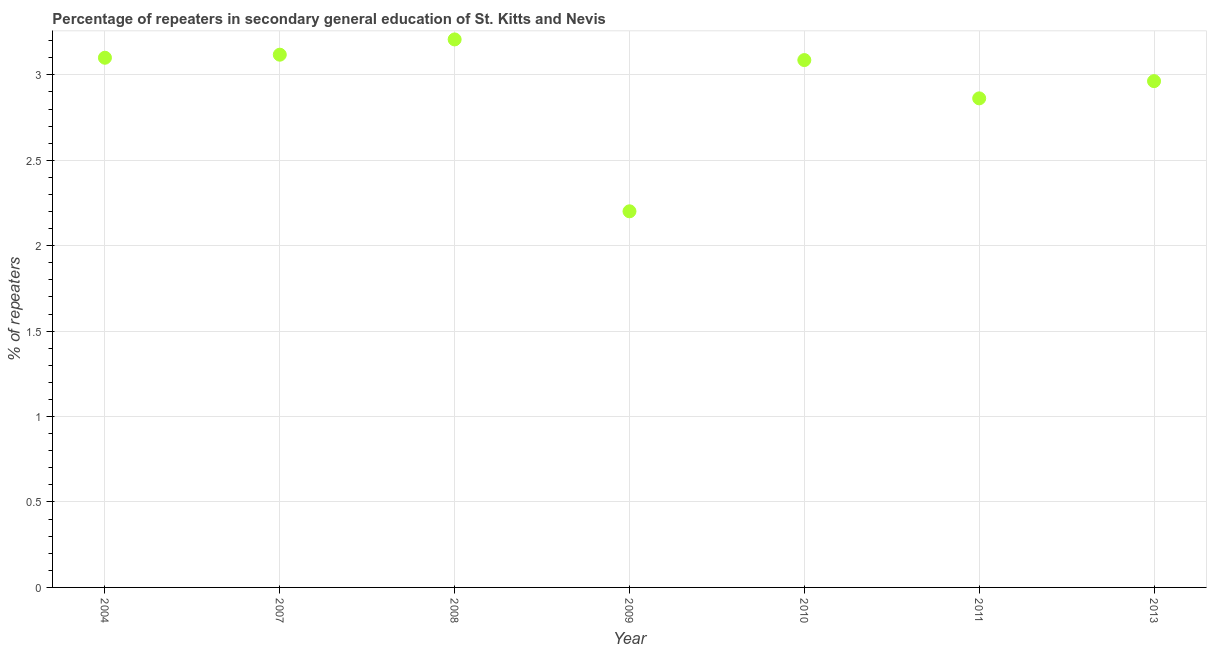What is the percentage of repeaters in 2009?
Make the answer very short. 2.2. Across all years, what is the maximum percentage of repeaters?
Keep it short and to the point. 3.21. Across all years, what is the minimum percentage of repeaters?
Offer a very short reply. 2.2. In which year was the percentage of repeaters minimum?
Offer a very short reply. 2009. What is the sum of the percentage of repeaters?
Ensure brevity in your answer.  20.54. What is the difference between the percentage of repeaters in 2009 and 2010?
Give a very brief answer. -0.89. What is the average percentage of repeaters per year?
Provide a short and direct response. 2.93. What is the median percentage of repeaters?
Offer a terse response. 3.09. In how many years, is the percentage of repeaters greater than 2.6 %?
Offer a terse response. 6. Do a majority of the years between 2009 and 2008 (inclusive) have percentage of repeaters greater than 2.1 %?
Give a very brief answer. No. What is the ratio of the percentage of repeaters in 2010 to that in 2013?
Offer a terse response. 1.04. Is the percentage of repeaters in 2009 less than that in 2011?
Ensure brevity in your answer.  Yes. What is the difference between the highest and the second highest percentage of repeaters?
Provide a short and direct response. 0.09. Is the sum of the percentage of repeaters in 2004 and 2007 greater than the maximum percentage of repeaters across all years?
Make the answer very short. Yes. What is the difference between the highest and the lowest percentage of repeaters?
Provide a short and direct response. 1.01. In how many years, is the percentage of repeaters greater than the average percentage of repeaters taken over all years?
Make the answer very short. 5. How many years are there in the graph?
Make the answer very short. 7. Are the values on the major ticks of Y-axis written in scientific E-notation?
Offer a terse response. No. Does the graph contain any zero values?
Offer a terse response. No. Does the graph contain grids?
Your response must be concise. Yes. What is the title of the graph?
Provide a succinct answer. Percentage of repeaters in secondary general education of St. Kitts and Nevis. What is the label or title of the Y-axis?
Keep it short and to the point. % of repeaters. What is the % of repeaters in 2004?
Keep it short and to the point. 3.1. What is the % of repeaters in 2007?
Give a very brief answer. 3.12. What is the % of repeaters in 2008?
Provide a succinct answer. 3.21. What is the % of repeaters in 2009?
Give a very brief answer. 2.2. What is the % of repeaters in 2010?
Make the answer very short. 3.09. What is the % of repeaters in 2011?
Your answer should be very brief. 2.86. What is the % of repeaters in 2013?
Provide a short and direct response. 2.96. What is the difference between the % of repeaters in 2004 and 2007?
Provide a short and direct response. -0.02. What is the difference between the % of repeaters in 2004 and 2008?
Give a very brief answer. -0.11. What is the difference between the % of repeaters in 2004 and 2009?
Provide a succinct answer. 0.9. What is the difference between the % of repeaters in 2004 and 2010?
Offer a very short reply. 0.01. What is the difference between the % of repeaters in 2004 and 2011?
Make the answer very short. 0.24. What is the difference between the % of repeaters in 2004 and 2013?
Your answer should be compact. 0.14. What is the difference between the % of repeaters in 2007 and 2008?
Provide a succinct answer. -0.09. What is the difference between the % of repeaters in 2007 and 2009?
Give a very brief answer. 0.92. What is the difference between the % of repeaters in 2007 and 2010?
Keep it short and to the point. 0.03. What is the difference between the % of repeaters in 2007 and 2011?
Your response must be concise. 0.26. What is the difference between the % of repeaters in 2007 and 2013?
Your answer should be compact. 0.15. What is the difference between the % of repeaters in 2008 and 2009?
Your answer should be compact. 1.01. What is the difference between the % of repeaters in 2008 and 2010?
Offer a terse response. 0.12. What is the difference between the % of repeaters in 2008 and 2011?
Keep it short and to the point. 0.34. What is the difference between the % of repeaters in 2008 and 2013?
Provide a short and direct response. 0.24. What is the difference between the % of repeaters in 2009 and 2010?
Offer a very short reply. -0.89. What is the difference between the % of repeaters in 2009 and 2011?
Provide a succinct answer. -0.66. What is the difference between the % of repeaters in 2009 and 2013?
Give a very brief answer. -0.76. What is the difference between the % of repeaters in 2010 and 2011?
Offer a terse response. 0.22. What is the difference between the % of repeaters in 2010 and 2013?
Provide a succinct answer. 0.12. What is the difference between the % of repeaters in 2011 and 2013?
Offer a very short reply. -0.1. What is the ratio of the % of repeaters in 2004 to that in 2008?
Offer a terse response. 0.97. What is the ratio of the % of repeaters in 2004 to that in 2009?
Offer a terse response. 1.41. What is the ratio of the % of repeaters in 2004 to that in 2011?
Offer a very short reply. 1.08. What is the ratio of the % of repeaters in 2004 to that in 2013?
Give a very brief answer. 1.05. What is the ratio of the % of repeaters in 2007 to that in 2009?
Ensure brevity in your answer.  1.42. What is the ratio of the % of repeaters in 2007 to that in 2011?
Provide a succinct answer. 1.09. What is the ratio of the % of repeaters in 2007 to that in 2013?
Offer a terse response. 1.05. What is the ratio of the % of repeaters in 2008 to that in 2009?
Your answer should be very brief. 1.46. What is the ratio of the % of repeaters in 2008 to that in 2010?
Give a very brief answer. 1.04. What is the ratio of the % of repeaters in 2008 to that in 2011?
Keep it short and to the point. 1.12. What is the ratio of the % of repeaters in 2008 to that in 2013?
Keep it short and to the point. 1.08. What is the ratio of the % of repeaters in 2009 to that in 2010?
Provide a succinct answer. 0.71. What is the ratio of the % of repeaters in 2009 to that in 2011?
Your response must be concise. 0.77. What is the ratio of the % of repeaters in 2009 to that in 2013?
Provide a short and direct response. 0.74. What is the ratio of the % of repeaters in 2010 to that in 2011?
Offer a very short reply. 1.08. What is the ratio of the % of repeaters in 2010 to that in 2013?
Your response must be concise. 1.04. What is the ratio of the % of repeaters in 2011 to that in 2013?
Keep it short and to the point. 0.97. 